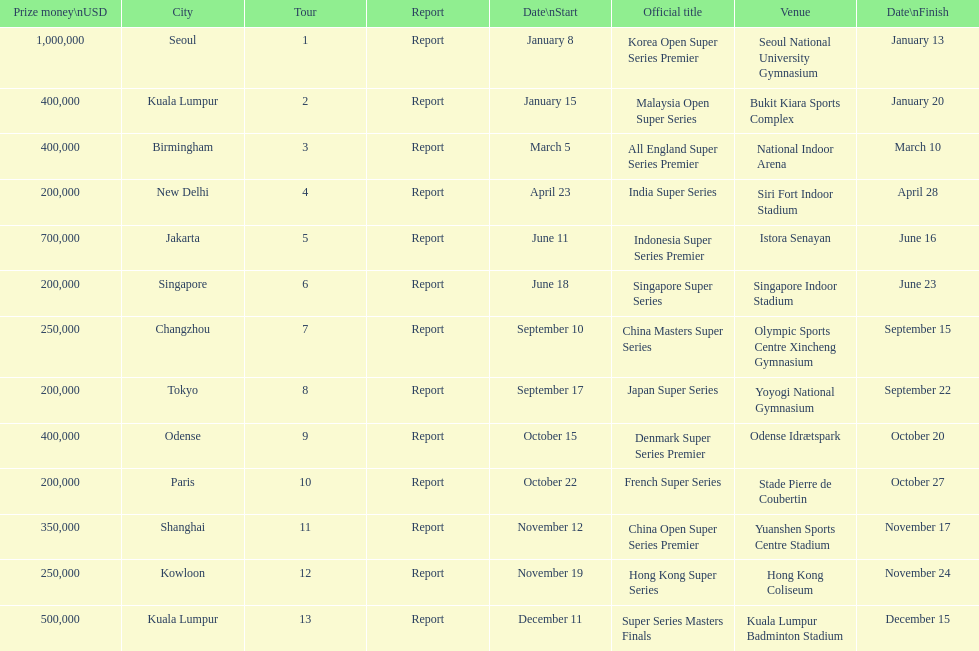How many events of the 2013 bwf super series pay over $200,000? 9. 